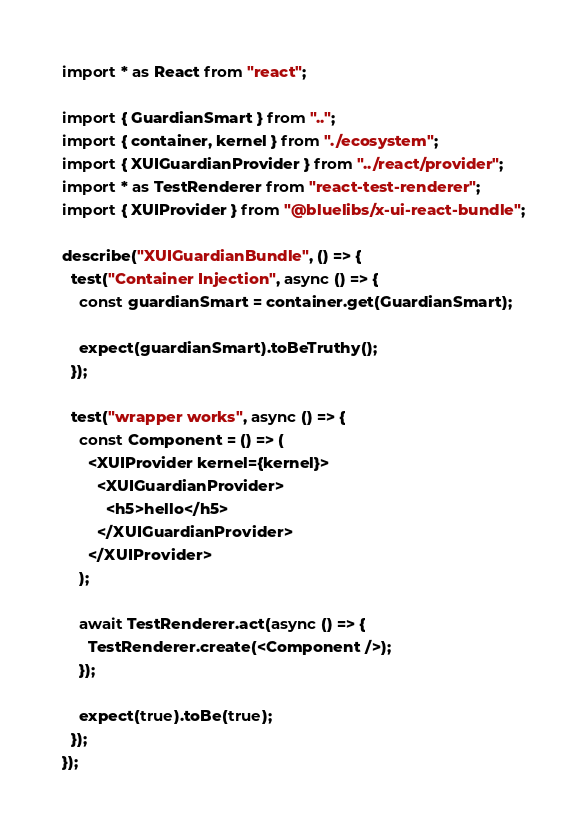<code> <loc_0><loc_0><loc_500><loc_500><_TypeScript_>import * as React from "react";

import { GuardianSmart } from "..";
import { container, kernel } from "./ecosystem";
import { XUIGuardianProvider } from "../react/provider";
import * as TestRenderer from "react-test-renderer";
import { XUIProvider } from "@bluelibs/x-ui-react-bundle";

describe("XUIGuardianBundle", () => {
  test("Container Injection", async () => {
    const guardianSmart = container.get(GuardianSmart);

    expect(guardianSmart).toBeTruthy();
  });

  test("wrapper works", async () => {
    const Component = () => (
      <XUIProvider kernel={kernel}>
        <XUIGuardianProvider>
          <h5>hello</h5>
        </XUIGuardianProvider>
      </XUIProvider>
    );

    await TestRenderer.act(async () => {
      TestRenderer.create(<Component />);
    });

    expect(true).toBe(true);
  });
});
</code> 